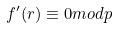Convert formula to latex. <formula><loc_0><loc_0><loc_500><loc_500>f ^ { \prime } ( r ) \equiv 0 m o d p</formula> 